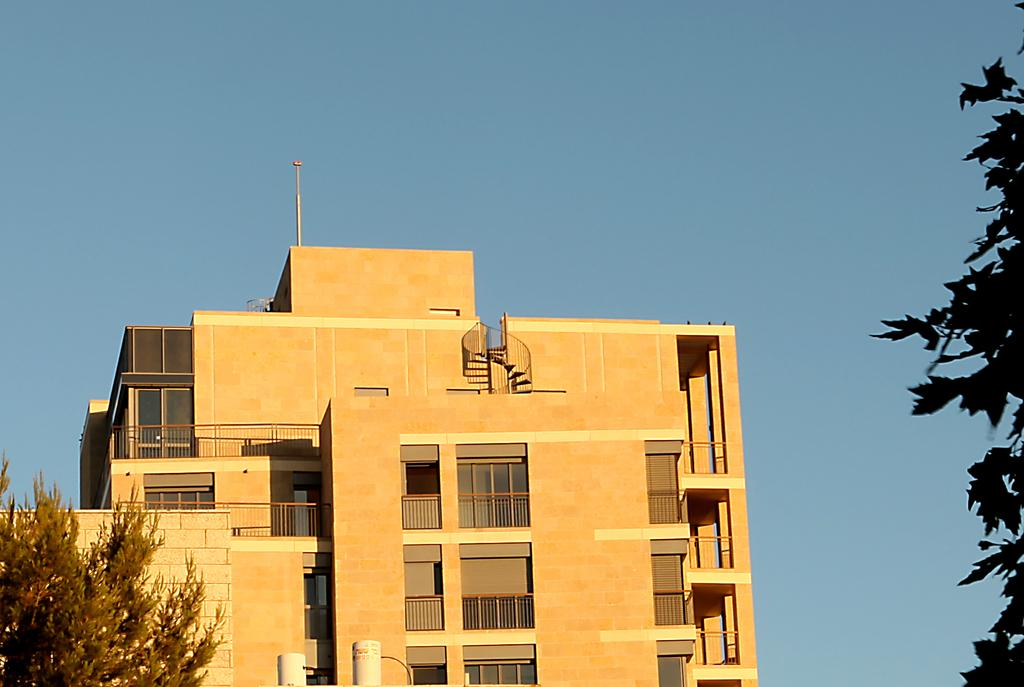What type of structure is visible in the image? There is a building in the image. What feature can be seen on the building? The building has windows. Is there any architectural element at the top of the building? Yes, there is a staircase at the top of the building. What type of vegetation is present near the building? Trees are present on either side of the building. How many bikes are parked near the building in the image? There are no bikes present in the image. What type of industry is depicted in the image? The image does not depict any industry; it features a building with trees on either side. 